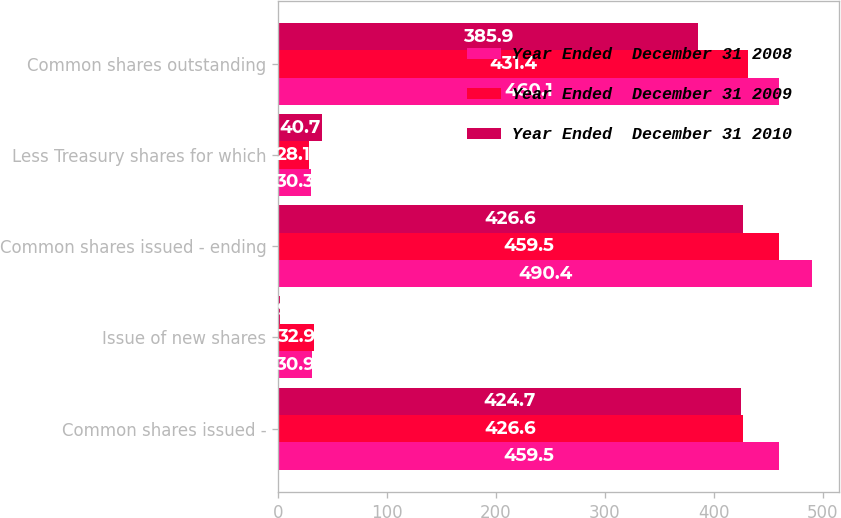Convert chart. <chart><loc_0><loc_0><loc_500><loc_500><stacked_bar_chart><ecel><fcel>Common shares issued -<fcel>Issue of new shares<fcel>Common shares issued - ending<fcel>Less Treasury shares for which<fcel>Common shares outstanding<nl><fcel>Year Ended  December 31 2008<fcel>459.5<fcel>30.9<fcel>490.4<fcel>30.3<fcel>460.1<nl><fcel>Year Ended  December 31 2009<fcel>426.6<fcel>32.9<fcel>459.5<fcel>28.1<fcel>431.4<nl><fcel>Year Ended  December 31 2010<fcel>424.7<fcel>1.9<fcel>426.6<fcel>40.7<fcel>385.9<nl></chart> 